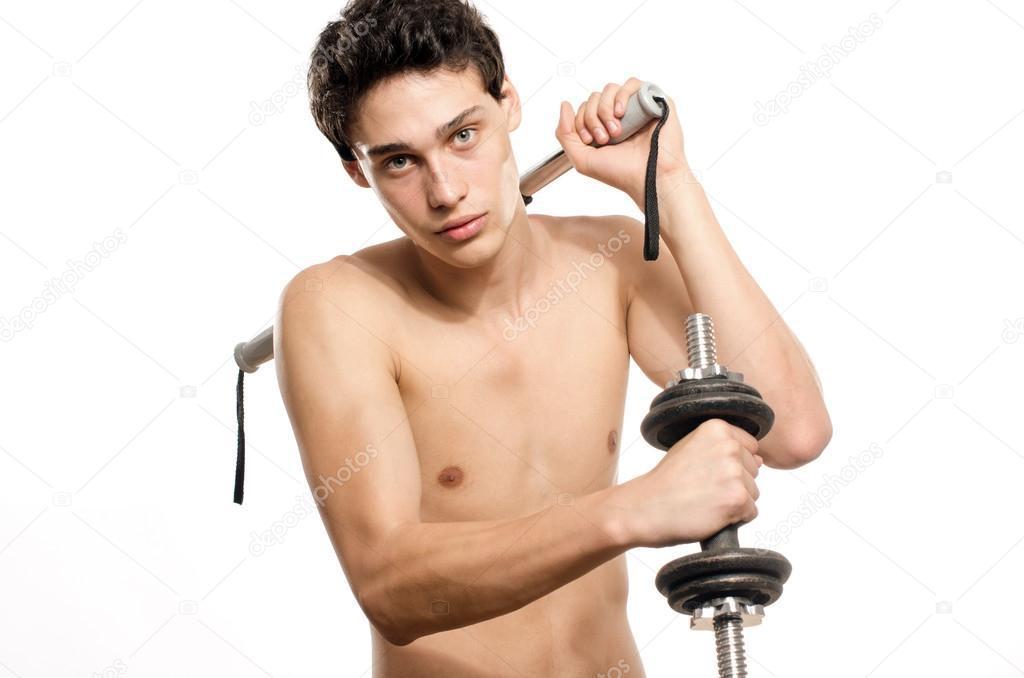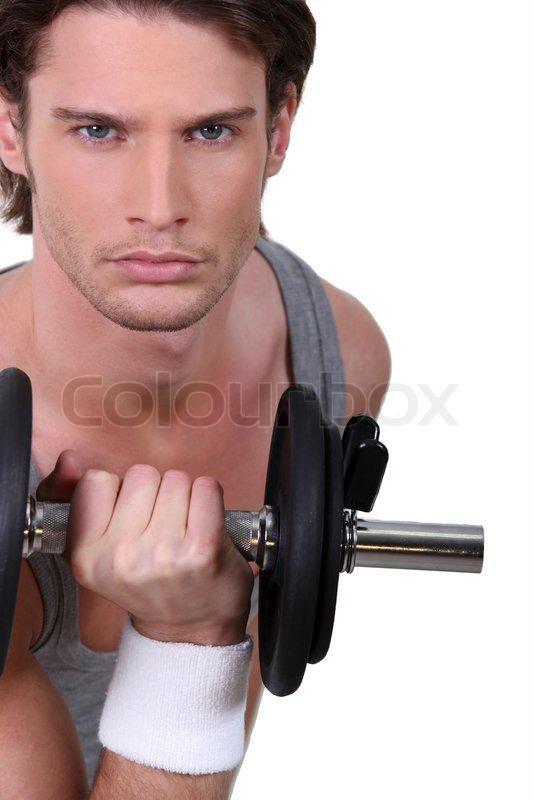The first image is the image on the left, the second image is the image on the right. For the images shown, is this caption "An image shows a man holding identical weights in each hand." true? Answer yes or no. No. 